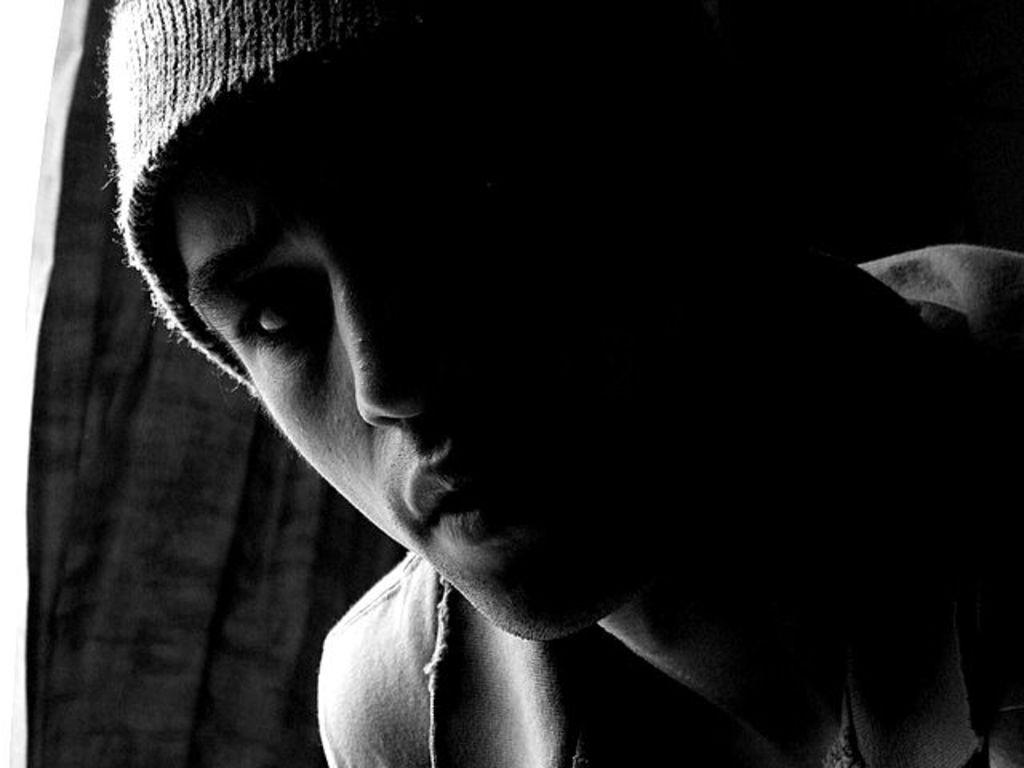What is the color scheme of the image? The image is black and white. Who or what is the main subject in the image? There is a person in the center of the image. What is the person wearing on their head? The person is wearing a hat. What can be seen in the background of the image? There is a curtain in the background of the image. How many tickets were distributed to the person in the image? There is no mention of tickets in the image, so it is impossible to determine how many were distributed. 